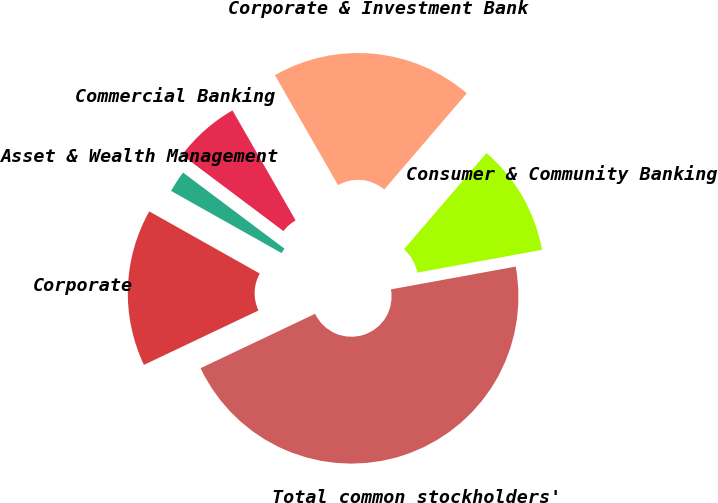<chart> <loc_0><loc_0><loc_500><loc_500><pie_chart><fcel>Consumer & Community Banking<fcel>Corporate & Investment Bank<fcel>Commercial Banking<fcel>Asset & Wealth Management<fcel>Corporate<fcel>Total common stockholders'<nl><fcel>10.84%<fcel>19.58%<fcel>6.46%<fcel>2.09%<fcel>15.21%<fcel>45.82%<nl></chart> 